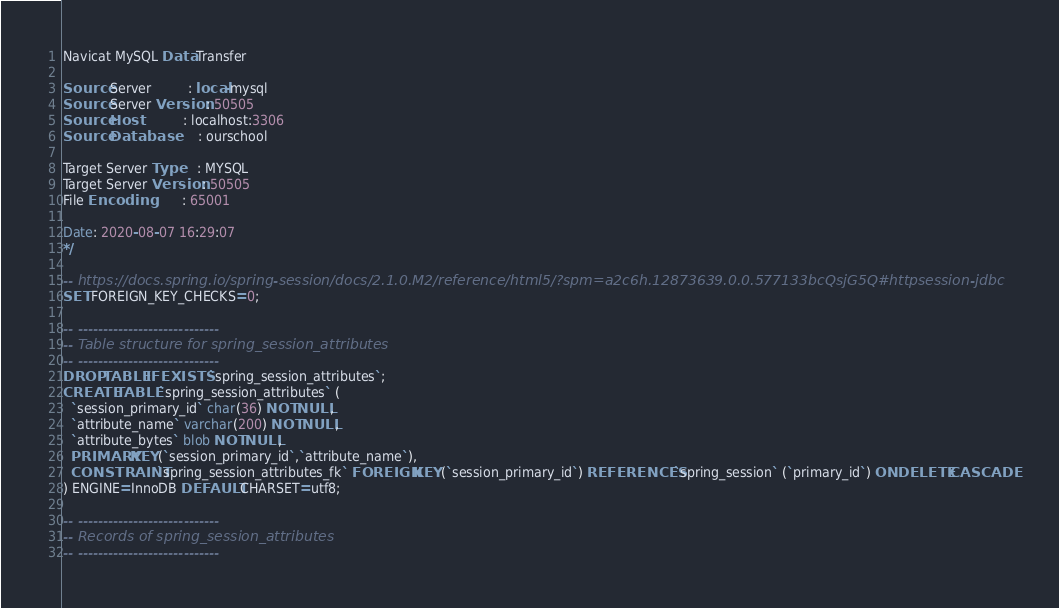<code> <loc_0><loc_0><loc_500><loc_500><_SQL_>Navicat MySQL Data Transfer

Source Server         : local-mysql
Source Server Version : 50505
Source Host           : localhost:3306
Source Database       : ourschool

Target Server Type    : MYSQL
Target Server Version : 50505
File Encoding         : 65001

Date: 2020-08-07 16:29:07
*/

-- https://docs.spring.io/spring-session/docs/2.1.0.M2/reference/html5/?spm=a2c6h.12873639.0.0.577133bcQsjG5Q#httpsession-jdbc
SET FOREIGN_KEY_CHECKS=0;

-- ----------------------------
-- Table structure for spring_session_attributes
-- ----------------------------
DROP TABLE IF EXISTS `spring_session_attributes`;
CREATE TABLE `spring_session_attributes` (
  `session_primary_id` char(36) NOT NULL,
  `attribute_name` varchar(200) NOT NULL,
  `attribute_bytes` blob NOT NULL,
  PRIMARY KEY (`session_primary_id`,`attribute_name`),
  CONSTRAINT `spring_session_attributes_fk` FOREIGN KEY (`session_primary_id`) REFERENCES `spring_session` (`primary_id`) ON DELETE CASCADE
) ENGINE=InnoDB DEFAULT CHARSET=utf8;

-- ----------------------------
-- Records of spring_session_attributes
-- ----------------------------
</code> 